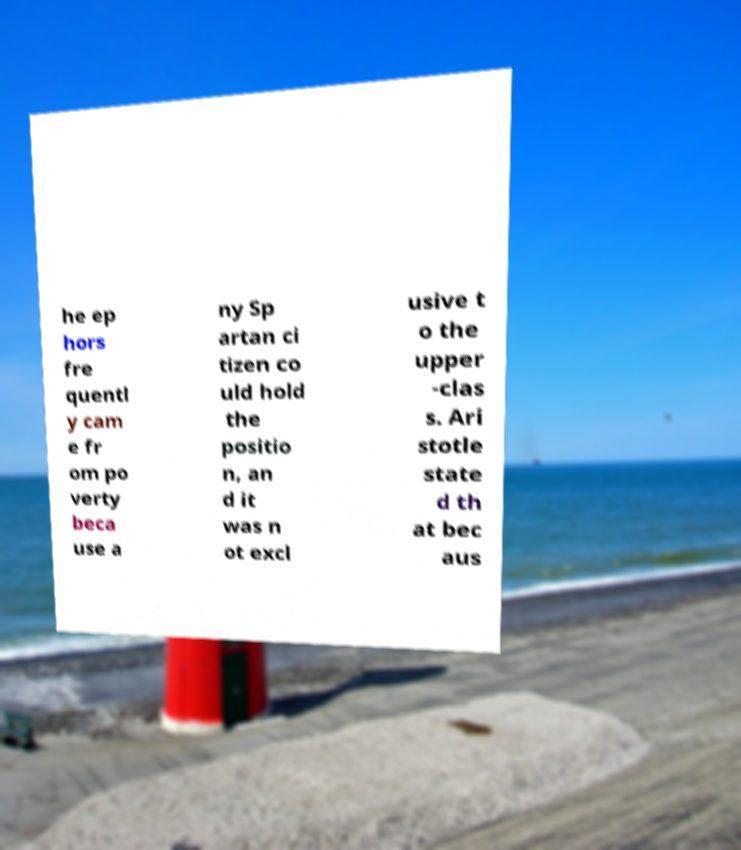Can you read and provide the text displayed in the image?This photo seems to have some interesting text. Can you extract and type it out for me? he ep hors fre quentl y cam e fr om po verty beca use a ny Sp artan ci tizen co uld hold the positio n, an d it was n ot excl usive t o the upper -clas s. Ari stotle state d th at bec aus 